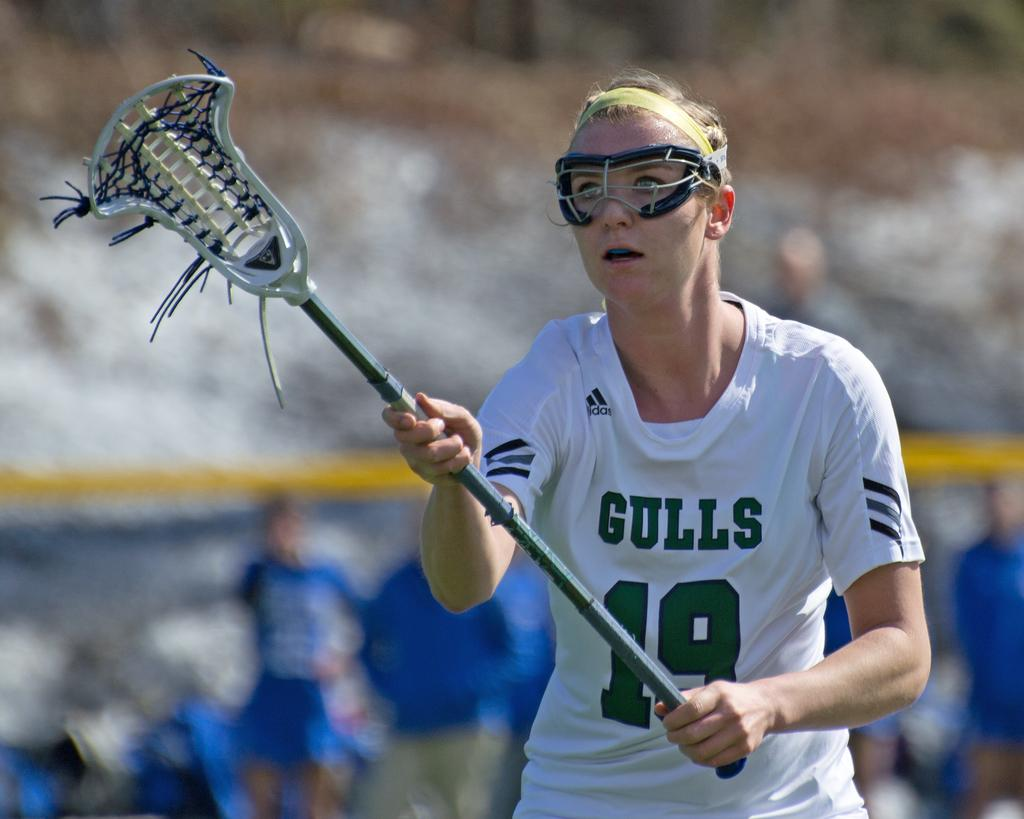What is the main subject of the image? There is a person standing in the center of the image. What is the person holding in the image? The person is holding an object. Can you describe the surroundings of the person? There are other persons visible in the background of the image, and there is a board present in the background. What type of leaf can be seen falling from the sky in the image? There is no leaf falling from the sky in the image. Can you describe the fish swimming near the person in the image? There is no fish present in the image. 